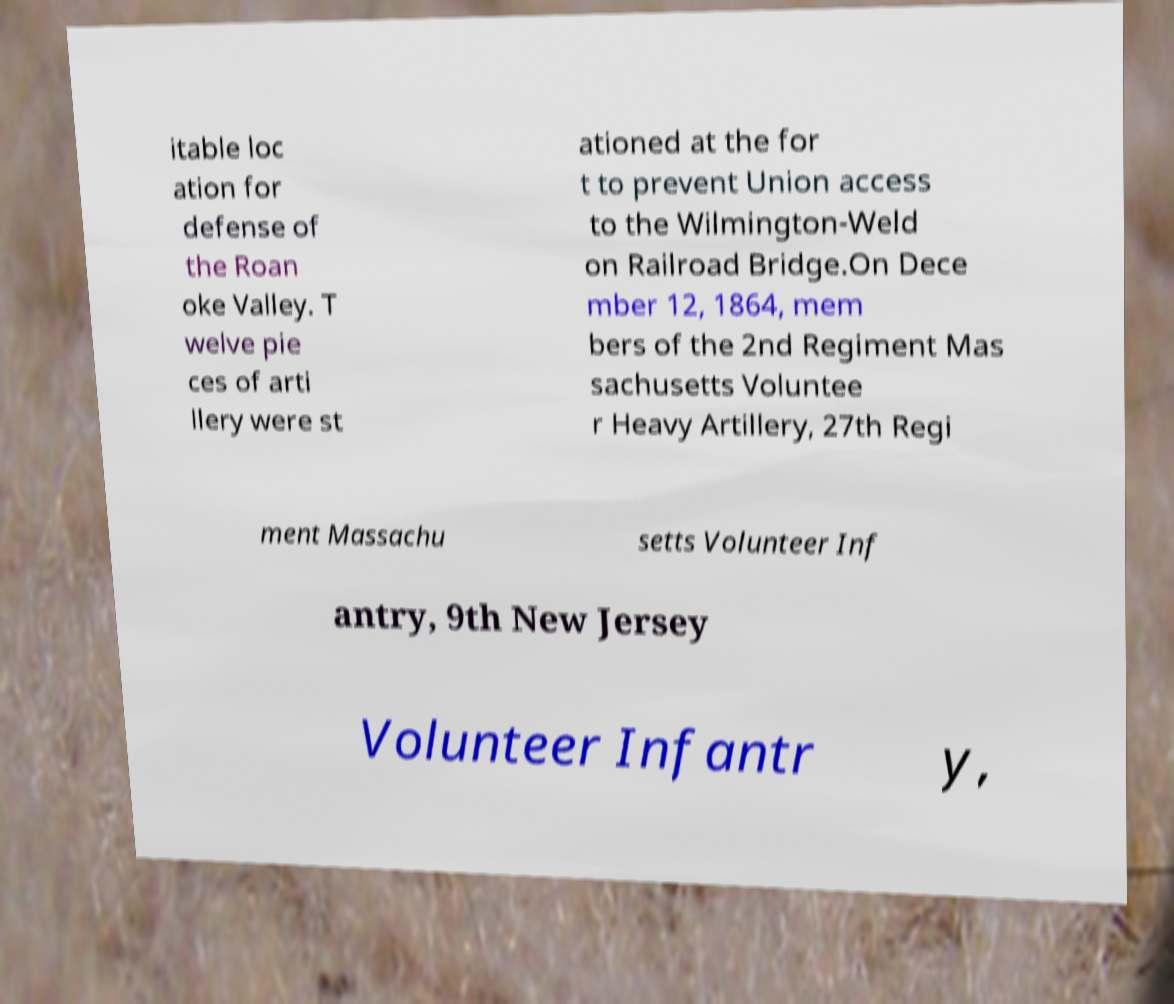There's text embedded in this image that I need extracted. Can you transcribe it verbatim? itable loc ation for defense of the Roan oke Valley. T welve pie ces of arti llery were st ationed at the for t to prevent Union access to the Wilmington-Weld on Railroad Bridge.On Dece mber 12, 1864, mem bers of the 2nd Regiment Mas sachusetts Voluntee r Heavy Artillery, 27th Regi ment Massachu setts Volunteer Inf antry, 9th New Jersey Volunteer Infantr y, 